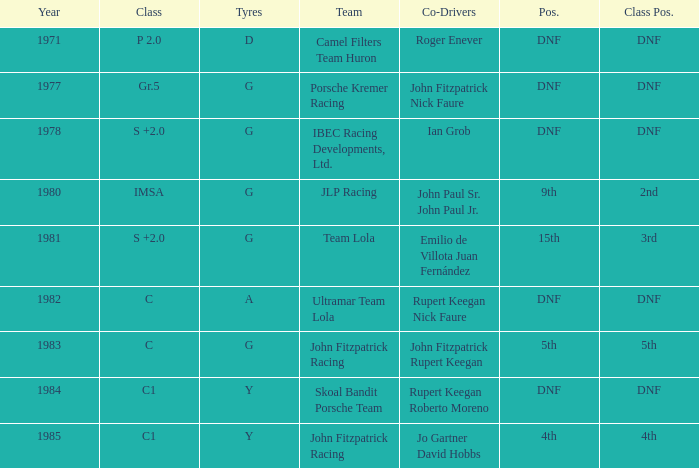What is the earliest year that had a co-driver of Roger Enever? 1971.0. 